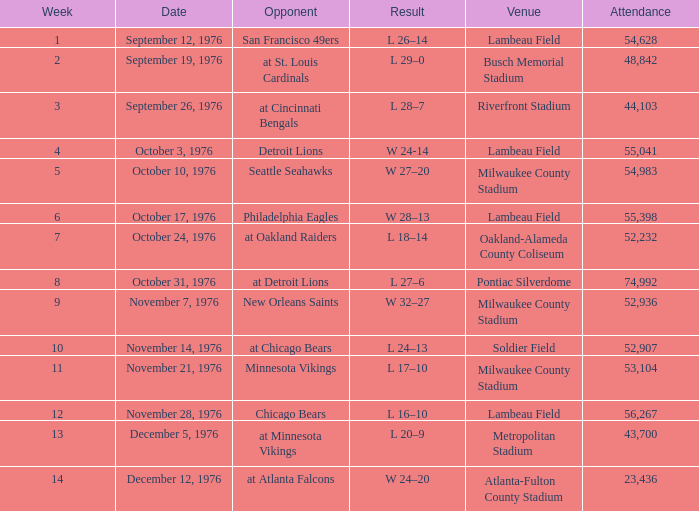How many individuals were present at the game on september 19, 1976? 1.0. 